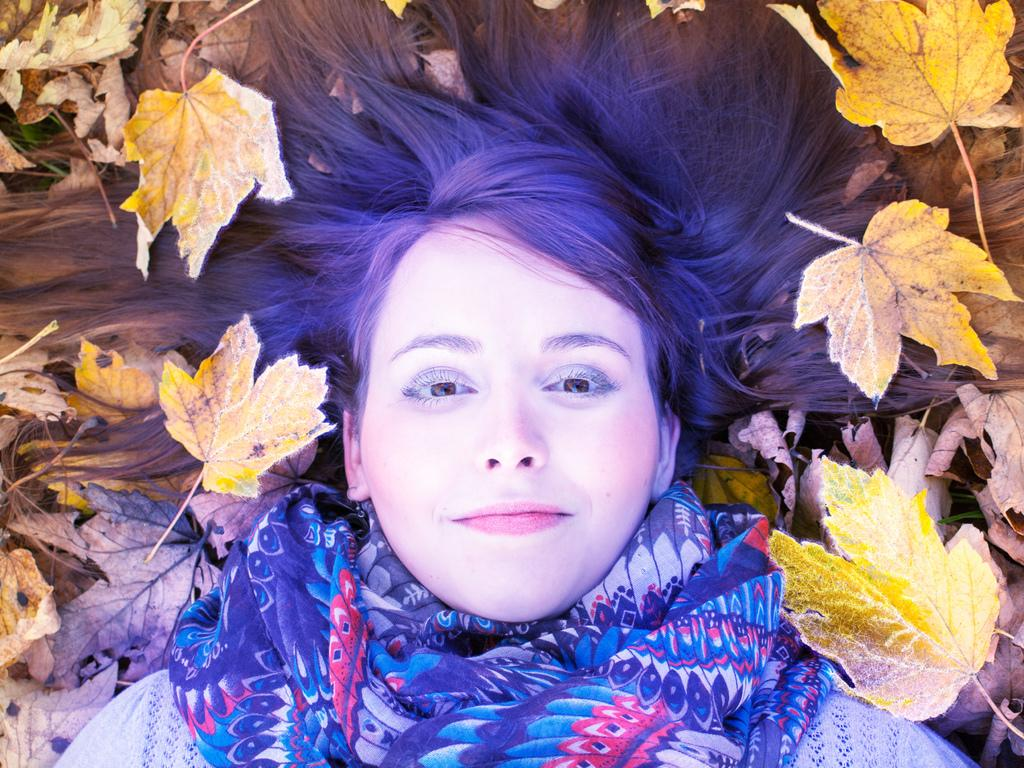What is the position of the woman in the image? The woman is lying on the ground in the image. What can be seen around the woman in the image? There are dried leaves around the woman in the image. How many seeds can be seen on the chair in the image? There is no chair present in the image, so it is not possible to determine the number of seeds on a chair. 